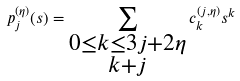<formula> <loc_0><loc_0><loc_500><loc_500>p ^ { ( \eta ) } _ { j } ( s ) = \sum _ { \substack { 0 \leq k \leq 3 j + 2 \eta \\ k + j } } c ^ { ( j , \eta ) } _ { k } s ^ { k }</formula> 